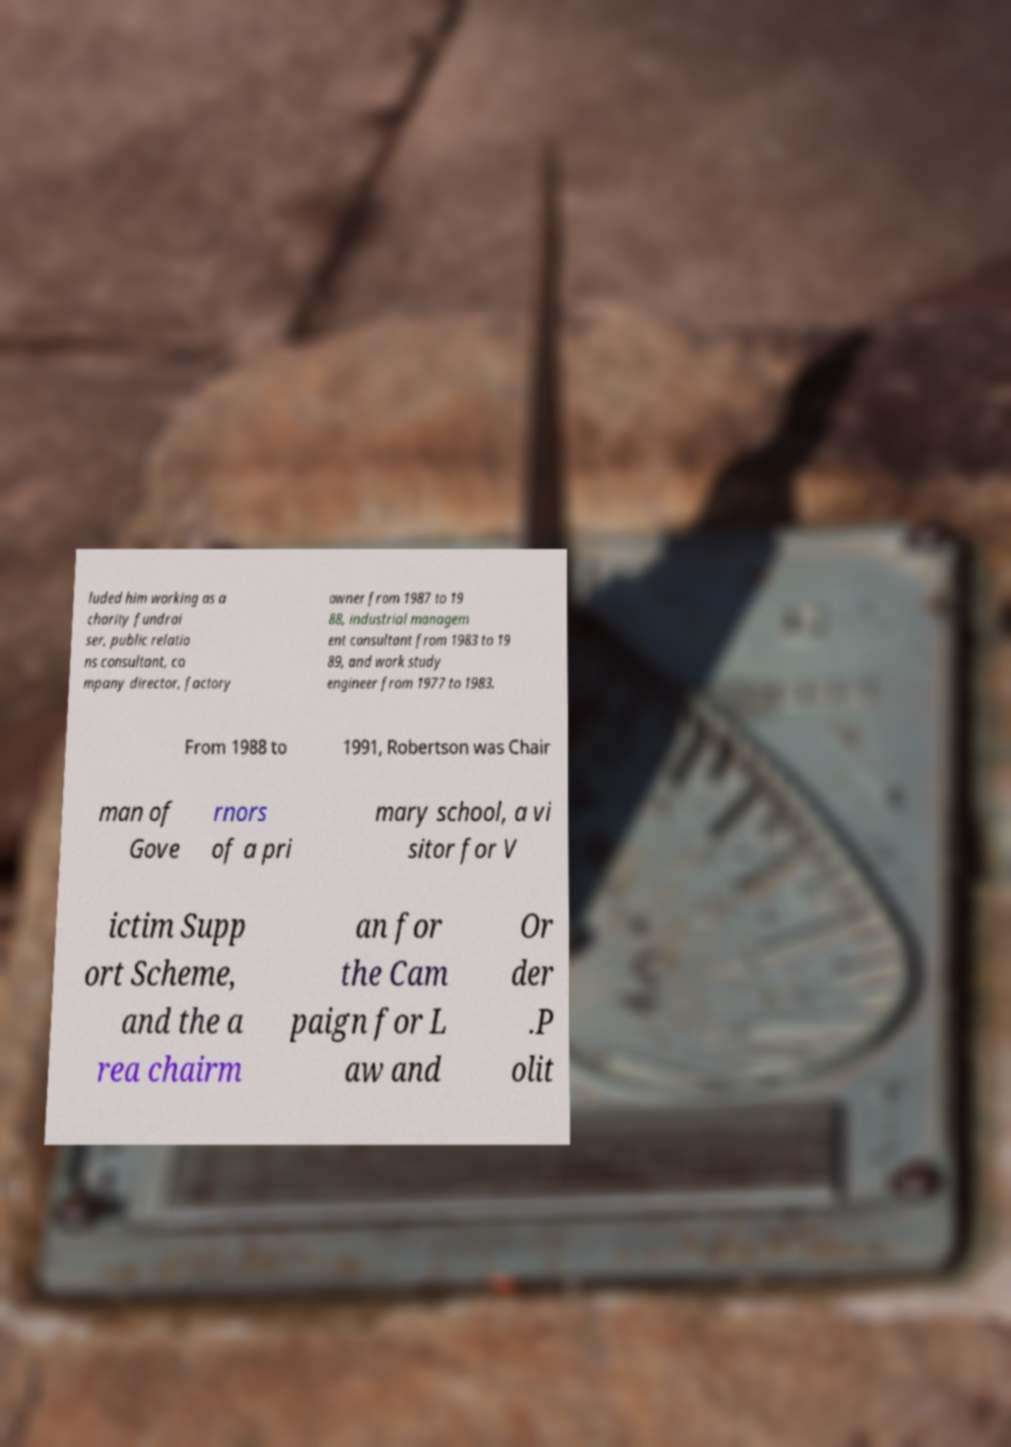Could you assist in decoding the text presented in this image and type it out clearly? luded him working as a charity fundrai ser, public relatio ns consultant, co mpany director, factory owner from 1987 to 19 88, industrial managem ent consultant from 1983 to 19 89, and work study engineer from 1977 to 1983. From 1988 to 1991, Robertson was Chair man of Gove rnors of a pri mary school, a vi sitor for V ictim Supp ort Scheme, and the a rea chairm an for the Cam paign for L aw and Or der .P olit 